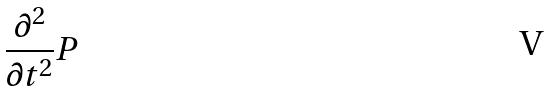Convert formula to latex. <formula><loc_0><loc_0><loc_500><loc_500>\frac { \partial ^ { 2 } } { \partial t ^ { 2 } } P</formula> 